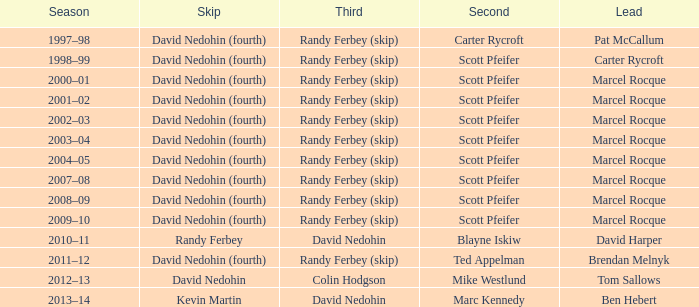When does ben hebert establish a lead? Marc Kennedy. 